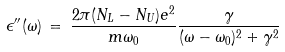Convert formula to latex. <formula><loc_0><loc_0><loc_500><loc_500>\epsilon ^ { \prime \prime } ( \omega ) \, = \, \frac { 2 \pi ( N _ { L } - N _ { U } ) e ^ { 2 } } { m \omega _ { 0 } } \frac { \gamma } { ( \omega - \omega _ { 0 } ) ^ { 2 } + \gamma ^ { 2 } }</formula> 